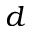Convert formula to latex. <formula><loc_0><loc_0><loc_500><loc_500>d</formula> 